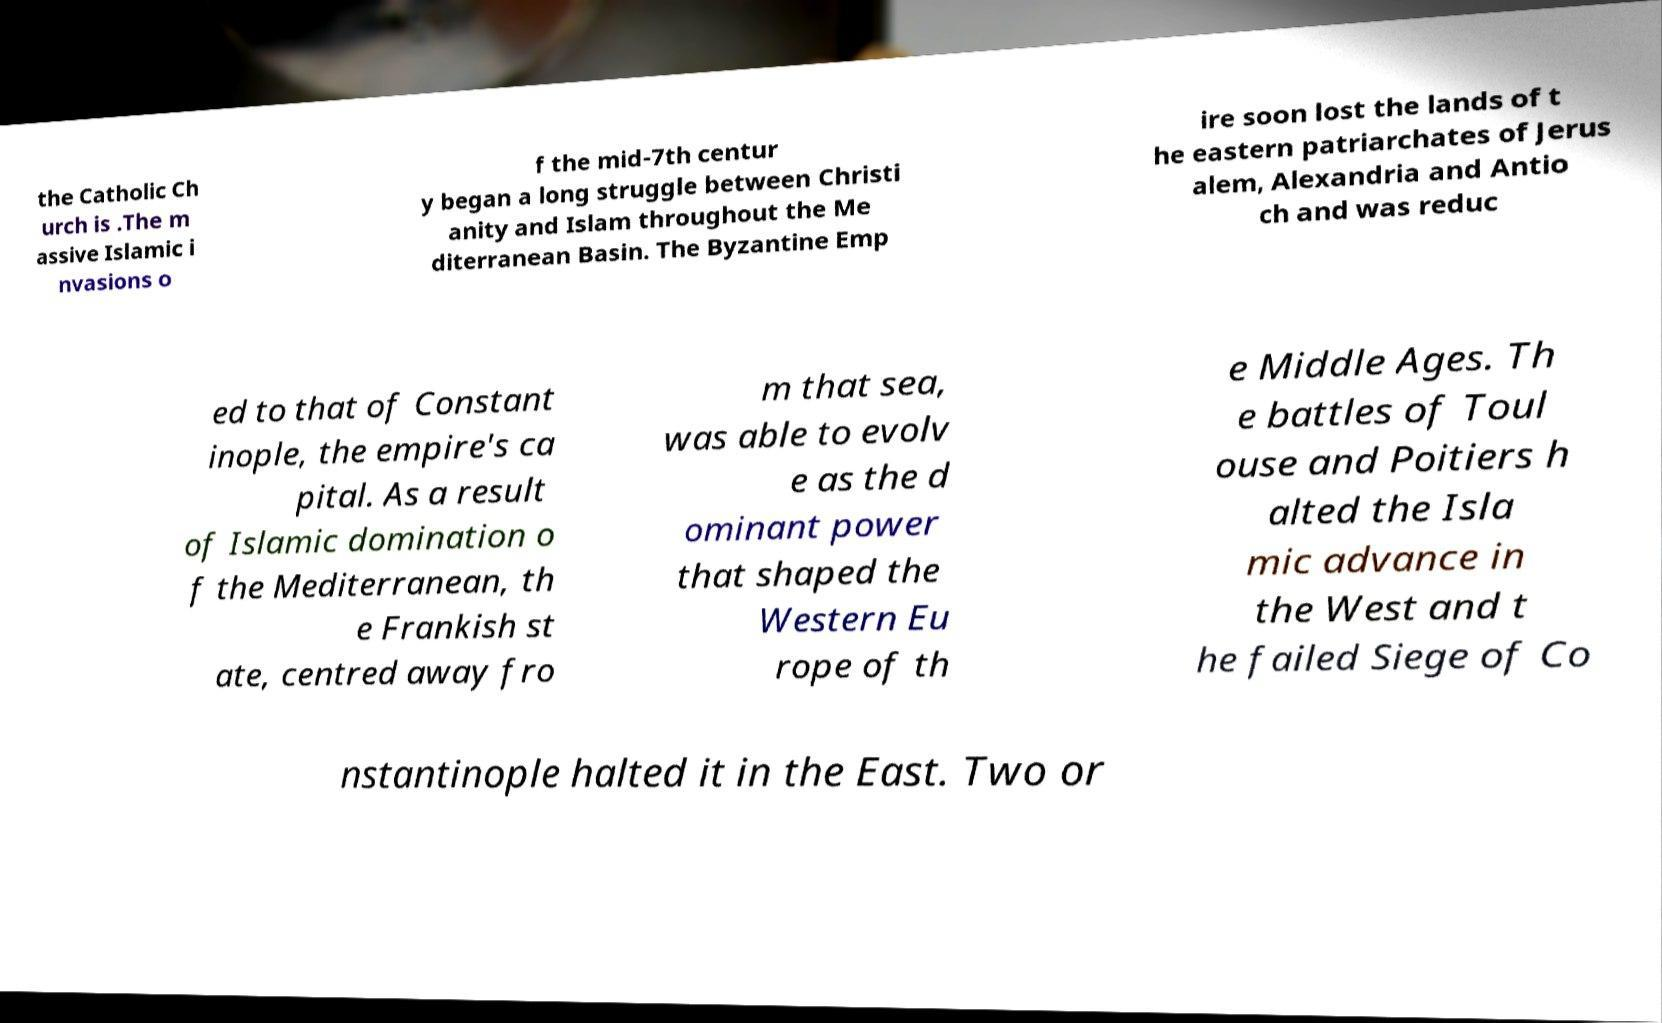Can you read and provide the text displayed in the image?This photo seems to have some interesting text. Can you extract and type it out for me? the Catholic Ch urch is .The m assive Islamic i nvasions o f the mid-7th centur y began a long struggle between Christi anity and Islam throughout the Me diterranean Basin. The Byzantine Emp ire soon lost the lands of t he eastern patriarchates of Jerus alem, Alexandria and Antio ch and was reduc ed to that of Constant inople, the empire's ca pital. As a result of Islamic domination o f the Mediterranean, th e Frankish st ate, centred away fro m that sea, was able to evolv e as the d ominant power that shaped the Western Eu rope of th e Middle Ages. Th e battles of Toul ouse and Poitiers h alted the Isla mic advance in the West and t he failed Siege of Co nstantinople halted it in the East. Two or 